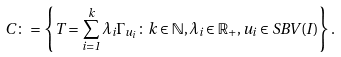<formula> <loc_0><loc_0><loc_500><loc_500>C \colon = \left \{ T = \sum _ { i = 1 } ^ { k } \lambda _ { i } \Gamma _ { u _ { i } } \colon k \in \mathbb { N } , \lambda _ { i } \in \mathbb { R } _ { + } , u _ { i } \in S B V ( I ) \right \} .</formula> 